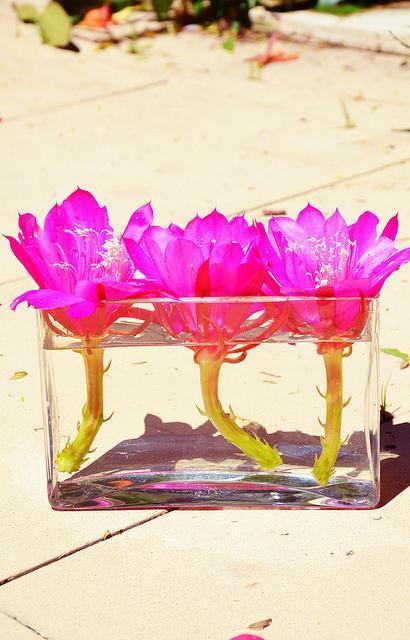How many clocks are there?
Give a very brief answer. 0. 